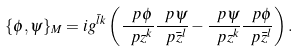Convert formula to latex. <formula><loc_0><loc_0><loc_500><loc_500>\{ \phi , \psi \} _ { M } = i g ^ { \bar { l } k } \left ( \frac { \ p \phi } { \ p z ^ { k } } \frac { \ p \psi } { \ p \bar { z } ^ { l } } - \frac { \ p \psi } { \ p z ^ { k } } \frac { \ p \phi } { \ p \bar { z } ^ { l } } \right ) .</formula> 